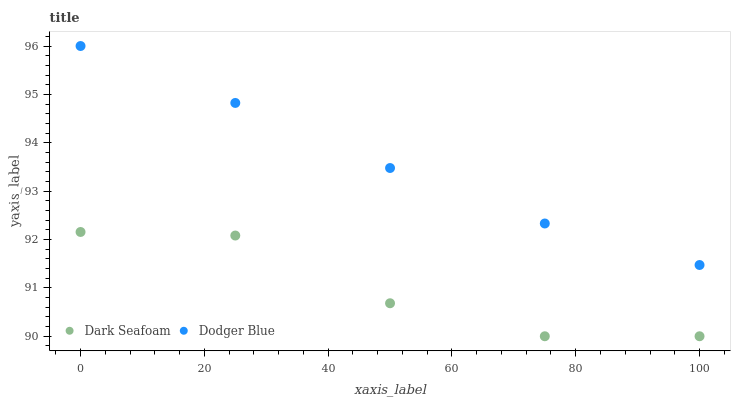Does Dark Seafoam have the minimum area under the curve?
Answer yes or no. Yes. Does Dodger Blue have the maximum area under the curve?
Answer yes or no. Yes. Does Dodger Blue have the minimum area under the curve?
Answer yes or no. No. Is Dodger Blue the smoothest?
Answer yes or no. Yes. Is Dark Seafoam the roughest?
Answer yes or no. Yes. Is Dodger Blue the roughest?
Answer yes or no. No. Does Dark Seafoam have the lowest value?
Answer yes or no. Yes. Does Dodger Blue have the lowest value?
Answer yes or no. No. Does Dodger Blue have the highest value?
Answer yes or no. Yes. Is Dark Seafoam less than Dodger Blue?
Answer yes or no. Yes. Is Dodger Blue greater than Dark Seafoam?
Answer yes or no. Yes. Does Dark Seafoam intersect Dodger Blue?
Answer yes or no. No. 